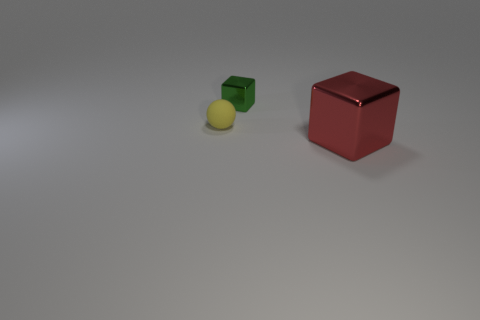How many large objects are cubes or green cubes? In the image, there are two large objects that are cubes. One cube is red, and the other is a green cube, making the total count of large cube objects one, which includes the green cube. 